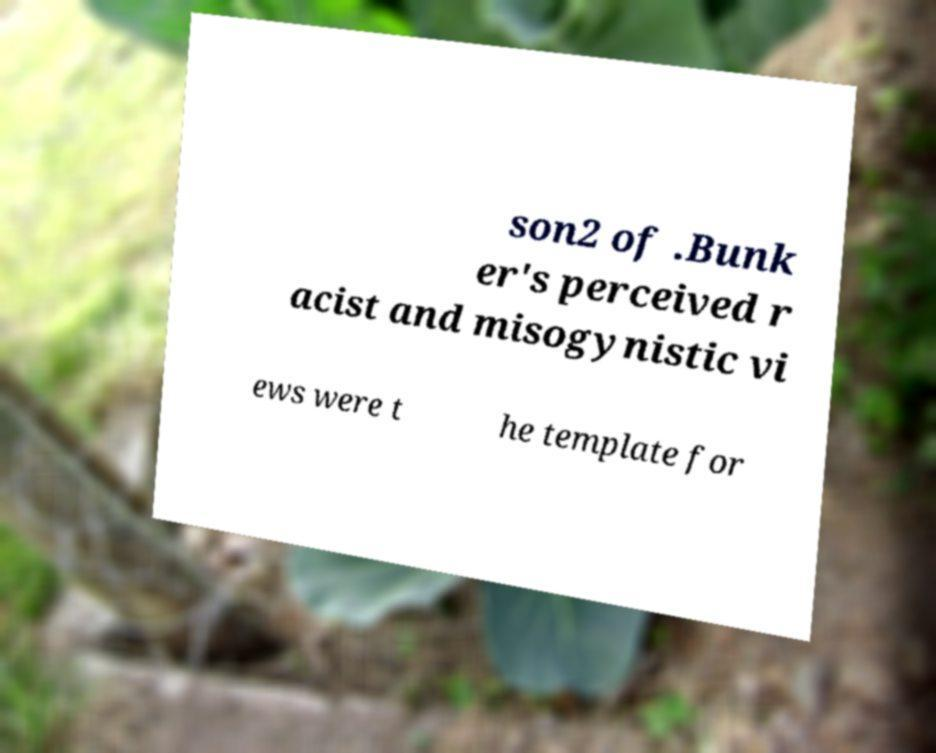I need the written content from this picture converted into text. Can you do that? son2 of .Bunk er's perceived r acist and misogynistic vi ews were t he template for 